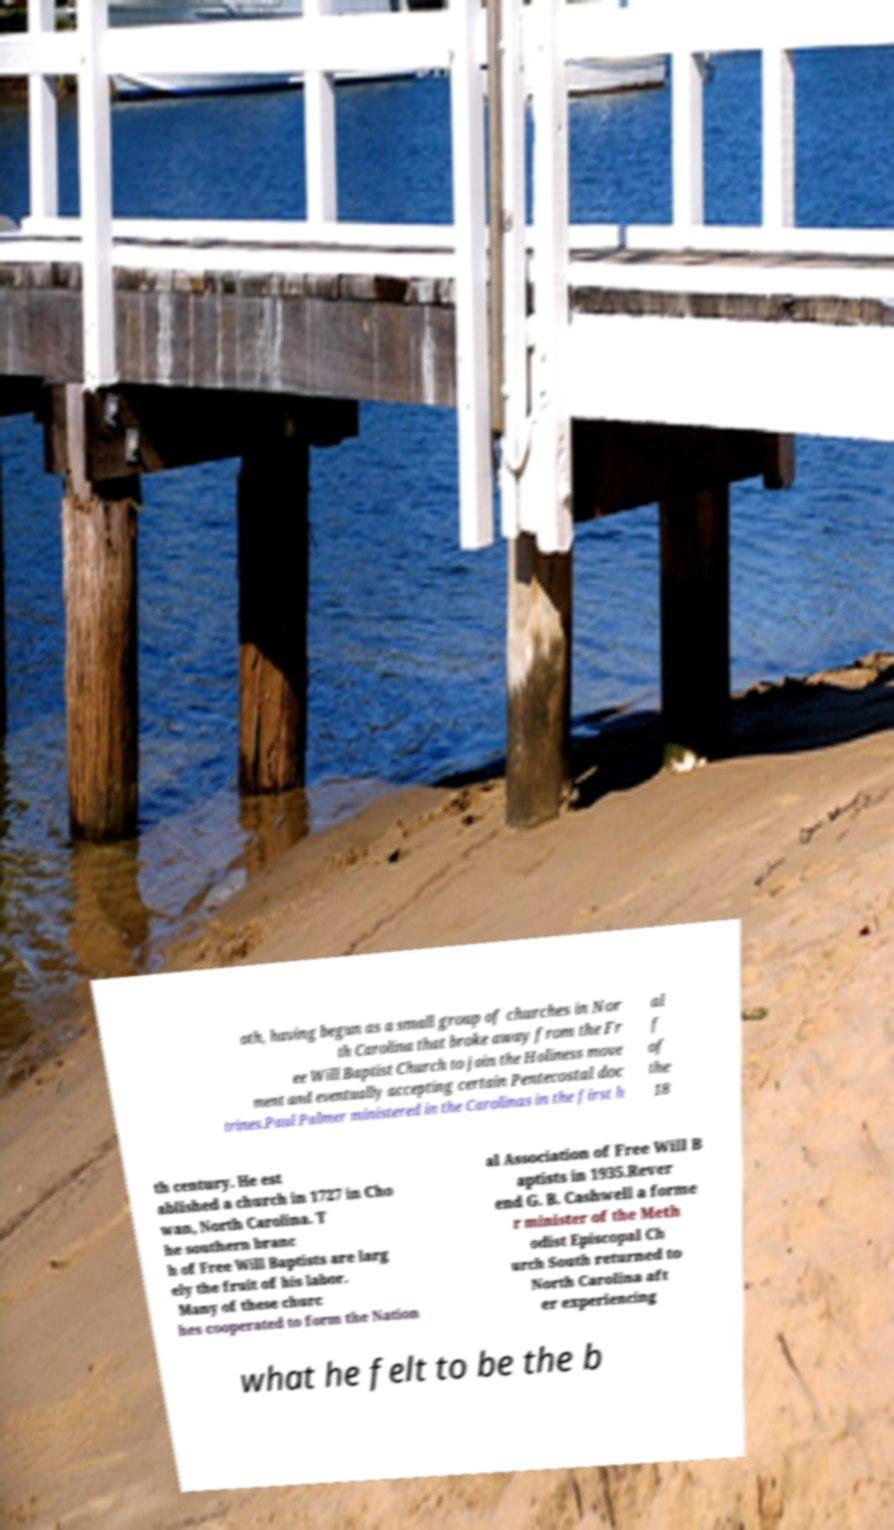There's text embedded in this image that I need extracted. Can you transcribe it verbatim? oth, having begun as a small group of churches in Nor th Carolina that broke away from the Fr ee Will Baptist Church to join the Holiness move ment and eventually accepting certain Pentecostal doc trines.Paul Palmer ministered in the Carolinas in the first h al f of the 18 th century. He est ablished a church in 1727 in Cho wan, North Carolina. T he southern branc h of Free Will Baptists are larg ely the fruit of his labor. Many of these churc hes cooperated to form the Nation al Association of Free Will B aptists in 1935.Rever end G. B. Cashwell a forme r minister of the Meth odist Episcopal Ch urch South returned to North Carolina aft er experiencing what he felt to be the b 